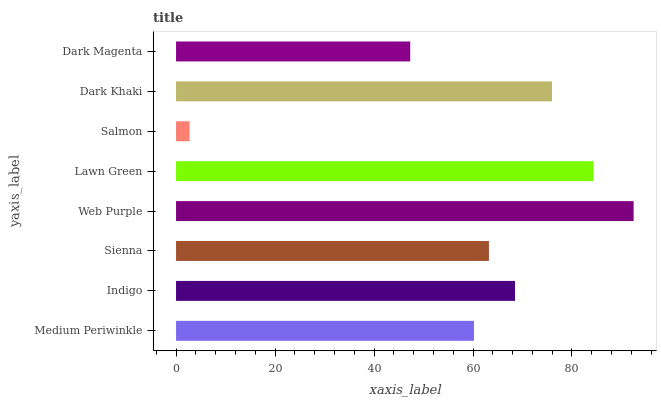Is Salmon the minimum?
Answer yes or no. Yes. Is Web Purple the maximum?
Answer yes or no. Yes. Is Indigo the minimum?
Answer yes or no. No. Is Indigo the maximum?
Answer yes or no. No. Is Indigo greater than Medium Periwinkle?
Answer yes or no. Yes. Is Medium Periwinkle less than Indigo?
Answer yes or no. Yes. Is Medium Periwinkle greater than Indigo?
Answer yes or no. No. Is Indigo less than Medium Periwinkle?
Answer yes or no. No. Is Indigo the high median?
Answer yes or no. Yes. Is Sienna the low median?
Answer yes or no. Yes. Is Sienna the high median?
Answer yes or no. No. Is Web Purple the low median?
Answer yes or no. No. 